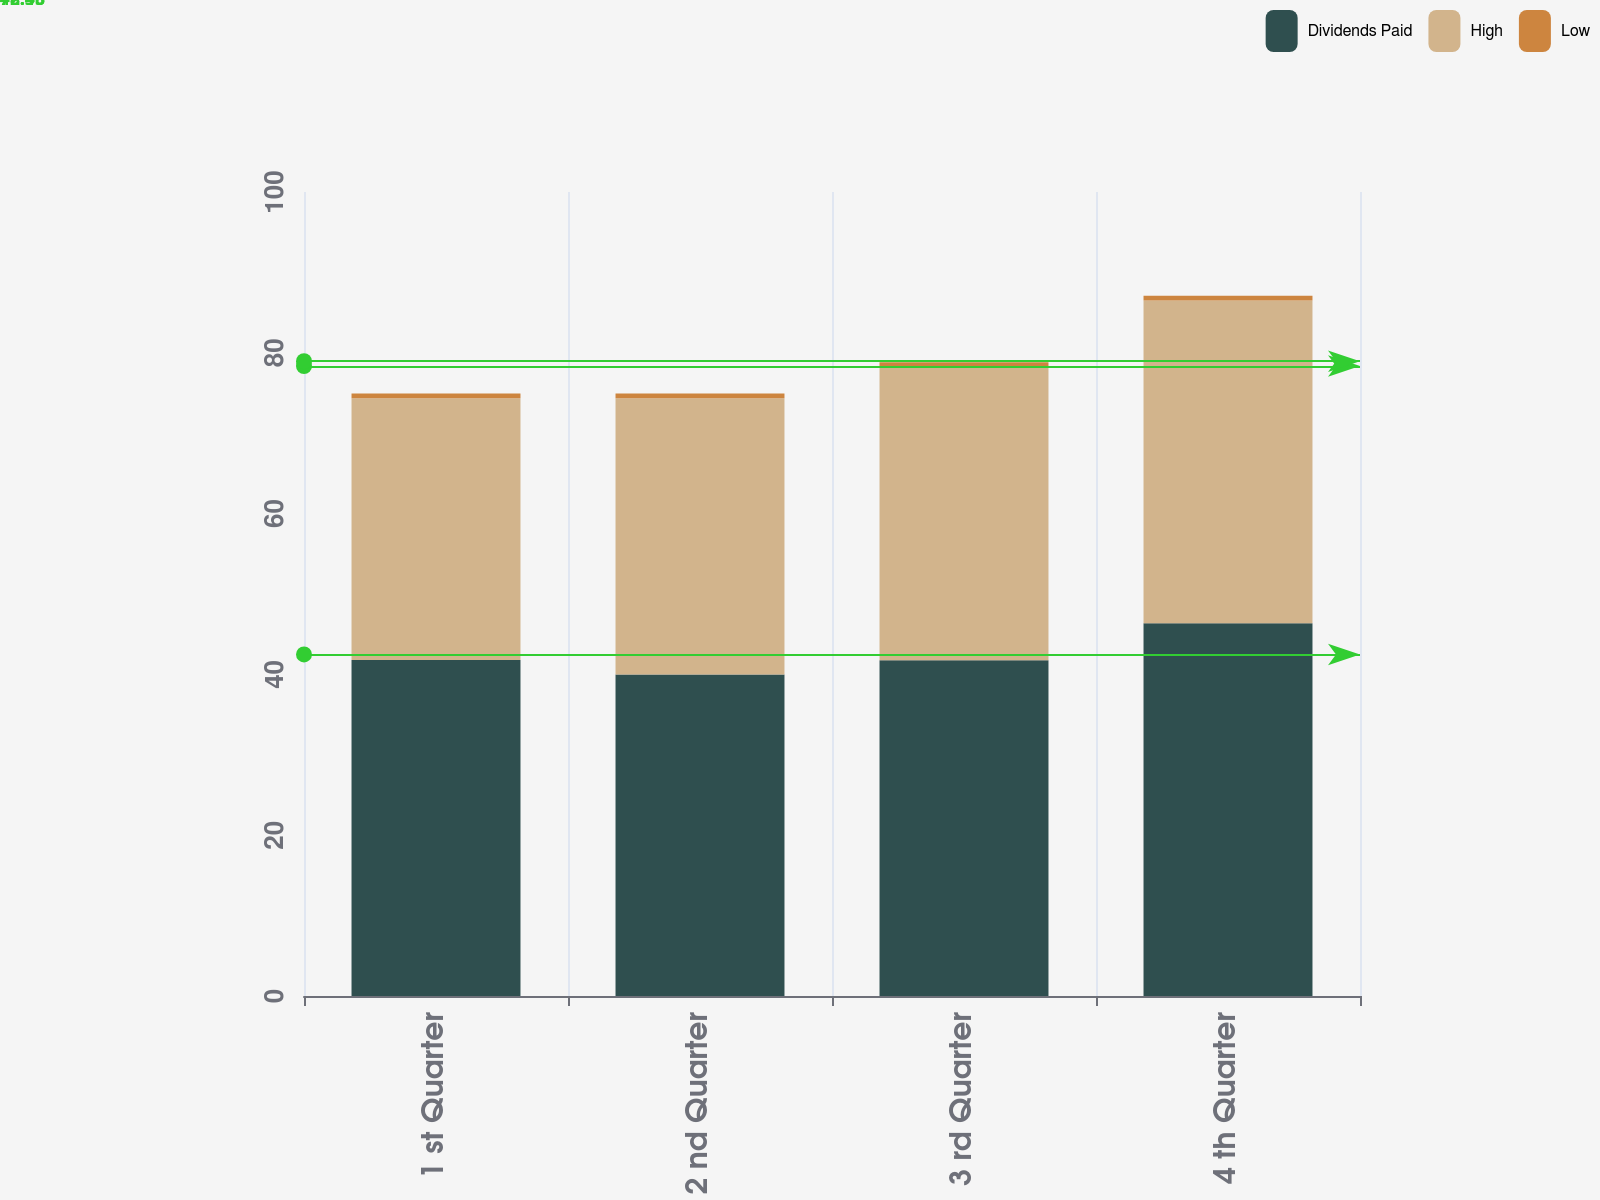<chart> <loc_0><loc_0><loc_500><loc_500><stacked_bar_chart><ecel><fcel>1 st Quarter<fcel>2 nd Quarter<fcel>3 rd Quarter<fcel>4 th Quarter<nl><fcel>Dividends Paid<fcel>41.79<fcel>40<fcel>41.77<fcel>46.35<nl><fcel>High<fcel>32.56<fcel>34.36<fcel>36.46<fcel>40.15<nl><fcel>Low<fcel>0.59<fcel>0.59<fcel>0.59<fcel>0.59<nl></chart> 